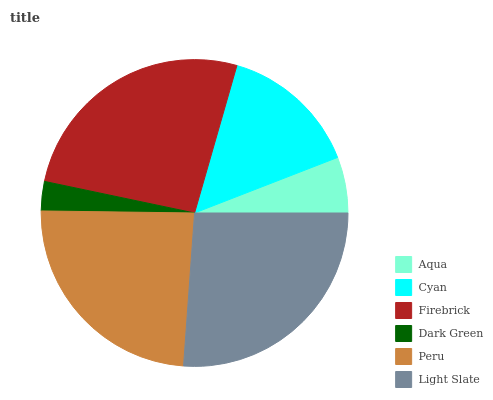Is Dark Green the minimum?
Answer yes or no. Yes. Is Firebrick the maximum?
Answer yes or no. Yes. Is Cyan the minimum?
Answer yes or no. No. Is Cyan the maximum?
Answer yes or no. No. Is Cyan greater than Aqua?
Answer yes or no. Yes. Is Aqua less than Cyan?
Answer yes or no. Yes. Is Aqua greater than Cyan?
Answer yes or no. No. Is Cyan less than Aqua?
Answer yes or no. No. Is Peru the high median?
Answer yes or no. Yes. Is Cyan the low median?
Answer yes or no. Yes. Is Dark Green the high median?
Answer yes or no. No. Is Peru the low median?
Answer yes or no. No. 